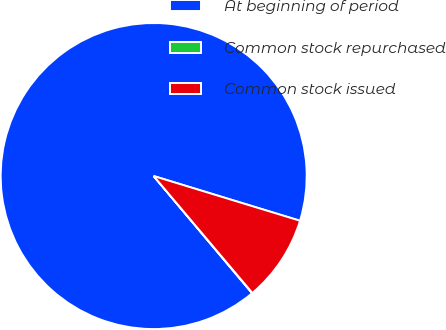Convert chart. <chart><loc_0><loc_0><loc_500><loc_500><pie_chart><fcel>At beginning of period<fcel>Common stock repurchased<fcel>Common stock issued<nl><fcel>90.84%<fcel>0.04%<fcel>9.12%<nl></chart> 